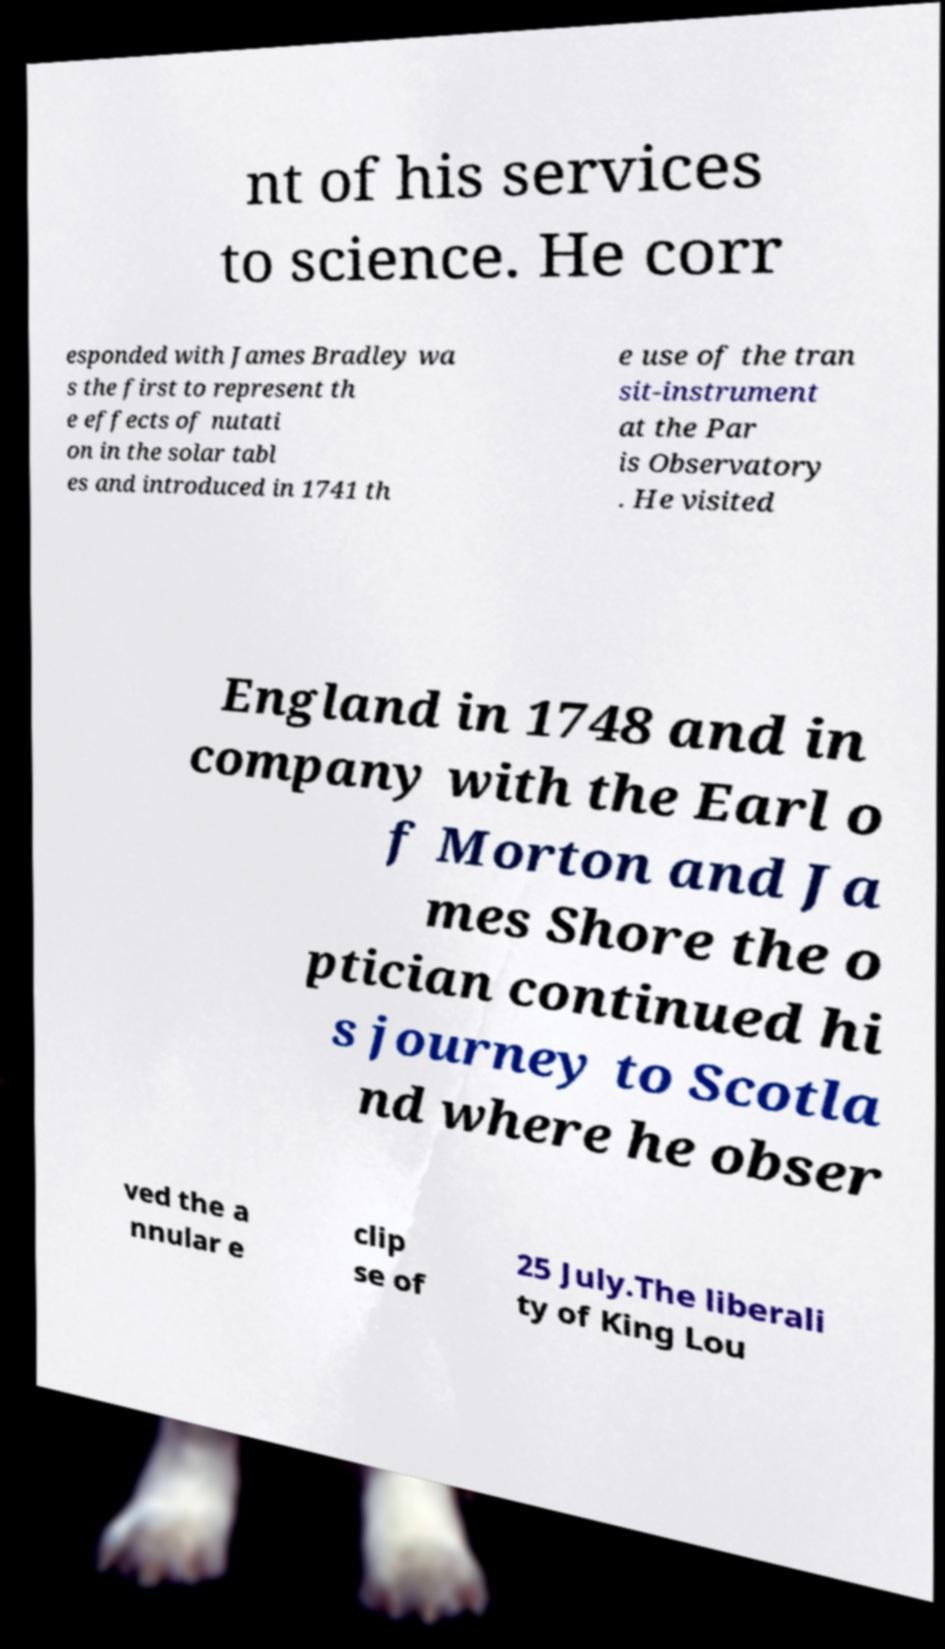Can you read and provide the text displayed in the image?This photo seems to have some interesting text. Can you extract and type it out for me? nt of his services to science. He corr esponded with James Bradley wa s the first to represent th e effects of nutati on in the solar tabl es and introduced in 1741 th e use of the tran sit-instrument at the Par is Observatory . He visited England in 1748 and in company with the Earl o f Morton and Ja mes Shore the o ptician continued hi s journey to Scotla nd where he obser ved the a nnular e clip se of 25 July.The liberali ty of King Lou 